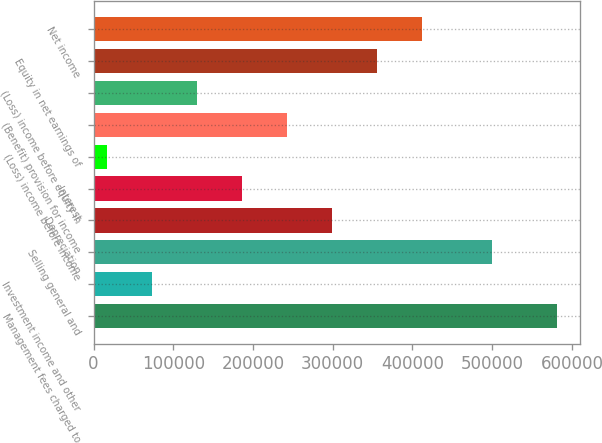Convert chart to OTSL. <chart><loc_0><loc_0><loc_500><loc_500><bar_chart><fcel>Management fees charged to<fcel>Investment income and other<fcel>Selling general and<fcel>Depreciation<fcel>Interest<fcel>(Loss) income before income<fcel>(Benefit) provision for income<fcel>(Loss) income before equity in<fcel>Equity in net earnings of<fcel>Net income<nl><fcel>581362<fcel>73739.5<fcel>499787<fcel>299350<fcel>186544<fcel>17337<fcel>242947<fcel>130142<fcel>355752<fcel>412154<nl></chart> 